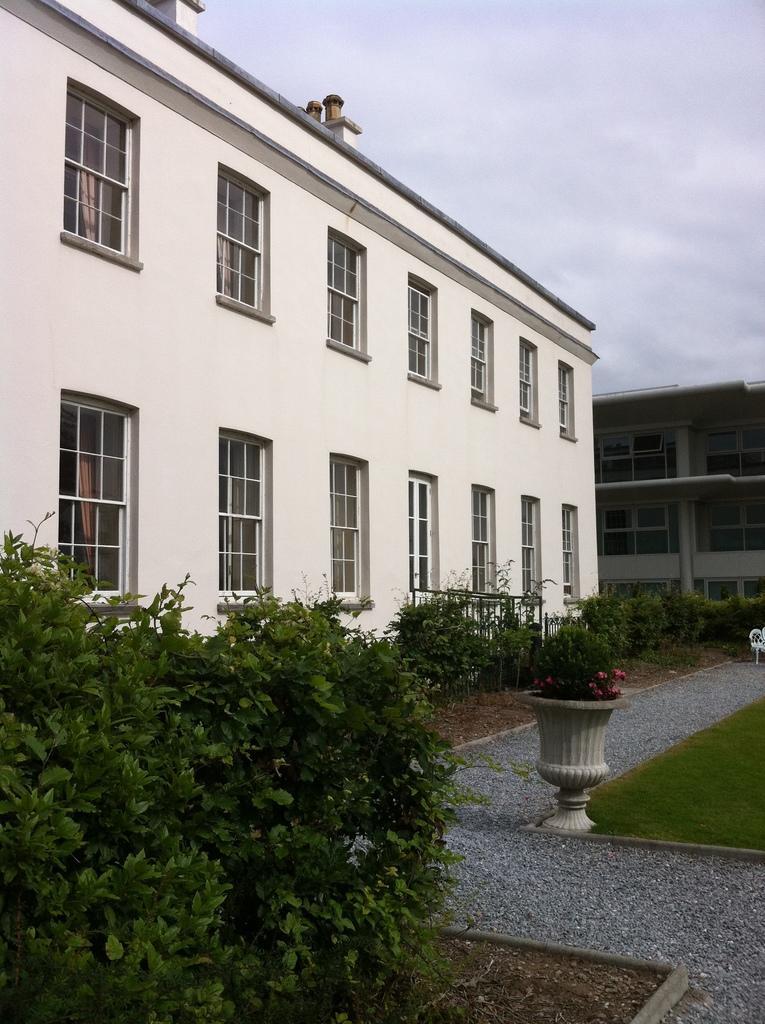In one or two sentences, can you explain what this image depicts? There are two buildings and in front of the first building there are many plants. Beside the plants there is a grass,at the left corner of the grass there is a flower plant,in the background there is a sky. 